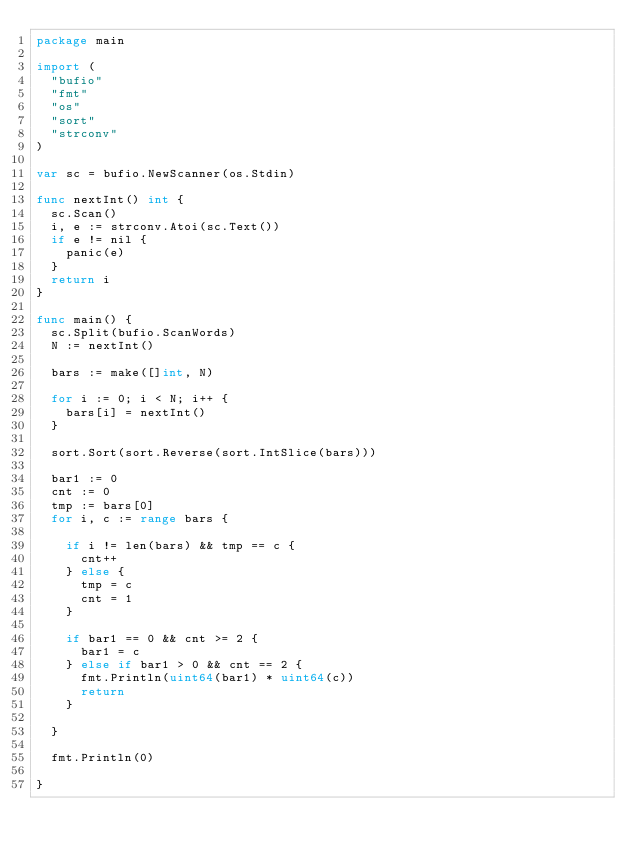<code> <loc_0><loc_0><loc_500><loc_500><_Go_>package main

import (
	"bufio"
	"fmt"
	"os"
	"sort"
	"strconv"
)

var sc = bufio.NewScanner(os.Stdin)

func nextInt() int {
	sc.Scan()
	i, e := strconv.Atoi(sc.Text())
	if e != nil {
		panic(e)
	}
	return i
}

func main() {
	sc.Split(bufio.ScanWords)
	N := nextInt()

	bars := make([]int, N)

	for i := 0; i < N; i++ {
		bars[i] = nextInt()
	}

	sort.Sort(sort.Reverse(sort.IntSlice(bars)))

	bar1 := 0
	cnt := 0
	tmp := bars[0]
	for i, c := range bars {

		if i != len(bars) && tmp == c {
			cnt++
		} else {
			tmp = c
			cnt = 1
		}

		if bar1 == 0 && cnt >= 2 {
			bar1 = c
		} else if bar1 > 0 && cnt == 2 {
			fmt.Println(uint64(bar1) * uint64(c))
			return
		}

	}

	fmt.Println(0)

}
</code> 